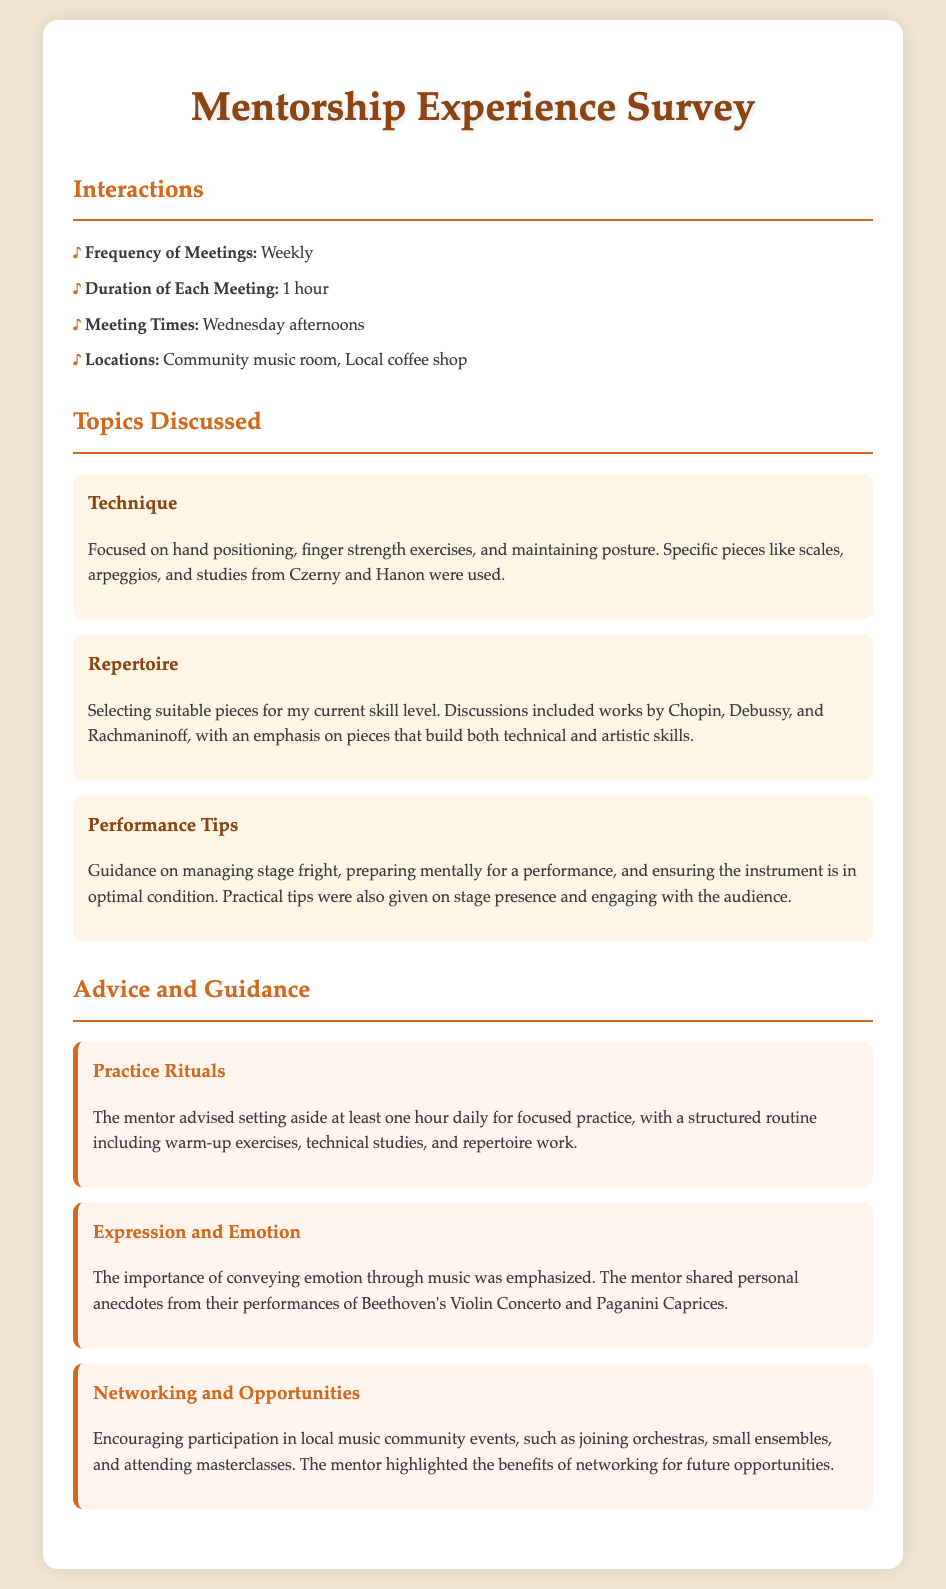What is the frequency of meetings? The frequency of meetings is specified in the document as how often the musician meets their mentor.
Answer: Weekly What day are the meetings held? The document provides specific details about the meeting times, which includes the day.
Answer: Wednesday afternoons What is the duration of each meeting? The document outlines how long each meeting lasts, which is a crucial detail for understanding the commitment involved.
Answer: 1 hour Which locations are mentioned for the meetings? The document lists specific places where the meetings occur, reflecting the setting of the interactions.
Answer: Community music room, Local coffee shop What topic discussed involves hand positioning? This question requires the reader to recall the specific focus of one of the topics discussed in meetings, per the document.
Answer: Technique Name a composer mentioned when discussing repertoire. The document highlights various composers whose works are discussed, which assists in understanding the repertoire selection.
Answer: Chopin What is a performance tip given to manage stage fright? This question draws on specific advice given during discussions about performance, requiring reasoning about the performance tips provided.
Answer: Managing stage fright How long should daily practice be according to the mentor's advice? The mentorship advice includes recommendations for structured practice routines, which encompass specific time commitments.
Answer: One hour What is emphasized as important for conveying emotion in music? This question prompts the reader to synthesize information relating to emotional expression shared by the mentor during discussions.
Answer: Expression and Emotion Which community activities does the mentor encourage participation in? The document indicates the mentor's guidance on the value of networking through community events, which is essential for future opportunities.
Answer: Local music community events 